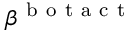Convert formula to latex. <formula><loc_0><loc_0><loc_500><loc_500>\beta ^ { b o t a c t }</formula> 